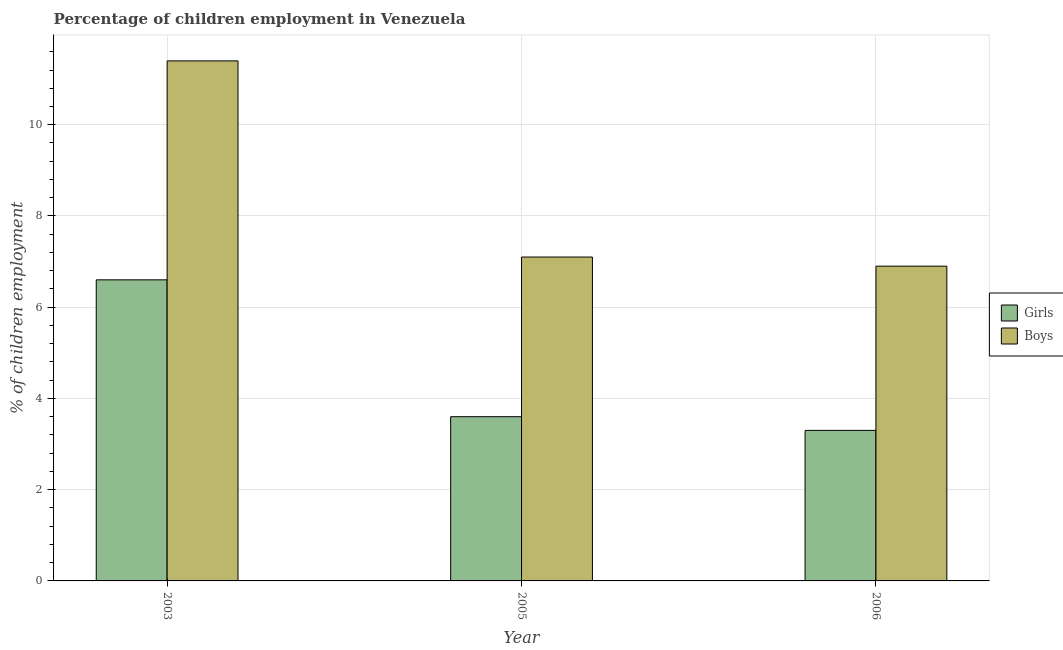How many groups of bars are there?
Your response must be concise. 3. How many bars are there on the 1st tick from the left?
Your answer should be very brief. 2. How many bars are there on the 2nd tick from the right?
Provide a succinct answer. 2. In how many cases, is the number of bars for a given year not equal to the number of legend labels?
Your answer should be very brief. 0. What is the percentage of employed boys in 2003?
Your response must be concise. 11.4. Across all years, what is the maximum percentage of employed boys?
Offer a terse response. 11.4. Across all years, what is the minimum percentage of employed boys?
Provide a short and direct response. 6.9. In which year was the percentage of employed boys minimum?
Offer a very short reply. 2006. What is the total percentage of employed boys in the graph?
Offer a very short reply. 25.4. What is the average percentage of employed boys per year?
Your response must be concise. 8.47. In the year 2005, what is the difference between the percentage of employed girls and percentage of employed boys?
Make the answer very short. 0. In how many years, is the percentage of employed girls greater than 8.4 %?
Provide a short and direct response. 0. What is the ratio of the percentage of employed girls in 2005 to that in 2006?
Provide a succinct answer. 1.09. Is the percentage of employed boys in 2005 less than that in 2006?
Provide a short and direct response. No. What is the difference between the highest and the second highest percentage of employed boys?
Ensure brevity in your answer.  4.3. What is the difference between the highest and the lowest percentage of employed girls?
Keep it short and to the point. 3.3. In how many years, is the percentage of employed girls greater than the average percentage of employed girls taken over all years?
Your response must be concise. 1. Is the sum of the percentage of employed girls in 2003 and 2006 greater than the maximum percentage of employed boys across all years?
Provide a succinct answer. Yes. What does the 2nd bar from the left in 2005 represents?
Your response must be concise. Boys. What does the 1st bar from the right in 2005 represents?
Your answer should be compact. Boys. Are all the bars in the graph horizontal?
Make the answer very short. No. Does the graph contain any zero values?
Your answer should be compact. No. Does the graph contain grids?
Offer a very short reply. Yes. Where does the legend appear in the graph?
Provide a succinct answer. Center right. How many legend labels are there?
Make the answer very short. 2. How are the legend labels stacked?
Your answer should be compact. Vertical. What is the title of the graph?
Ensure brevity in your answer.  Percentage of children employment in Venezuela. Does "Working capital" appear as one of the legend labels in the graph?
Offer a terse response. No. What is the label or title of the Y-axis?
Ensure brevity in your answer.  % of children employment. What is the % of children employment of Girls in 2003?
Offer a terse response. 6.6. What is the % of children employment of Girls in 2005?
Your response must be concise. 3.6. Across all years, what is the maximum % of children employment in Boys?
Your answer should be very brief. 11.4. What is the total % of children employment in Girls in the graph?
Keep it short and to the point. 13.5. What is the total % of children employment of Boys in the graph?
Offer a terse response. 25.4. What is the difference between the % of children employment of Boys in 2003 and that in 2005?
Give a very brief answer. 4.3. What is the difference between the % of children employment in Boys in 2005 and that in 2006?
Offer a very short reply. 0.2. What is the average % of children employment in Girls per year?
Make the answer very short. 4.5. What is the average % of children employment of Boys per year?
Offer a terse response. 8.47. In the year 2006, what is the difference between the % of children employment of Girls and % of children employment of Boys?
Make the answer very short. -3.6. What is the ratio of the % of children employment of Girls in 2003 to that in 2005?
Make the answer very short. 1.83. What is the ratio of the % of children employment in Boys in 2003 to that in 2005?
Make the answer very short. 1.61. What is the ratio of the % of children employment in Boys in 2003 to that in 2006?
Provide a succinct answer. 1.65. What is the difference between the highest and the second highest % of children employment of Boys?
Make the answer very short. 4.3. What is the difference between the highest and the lowest % of children employment of Girls?
Provide a succinct answer. 3.3. 